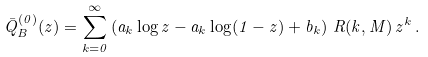Convert formula to latex. <formula><loc_0><loc_0><loc_500><loc_500>\bar { Q } ^ { ( 0 ) } _ { B } ( z ) = \sum ^ { \infty } _ { k = 0 } \left ( a _ { k } \log z - a _ { k } \log ( 1 - z ) + b _ { k } \right ) \, R ( k , M ) \, z ^ { k } \, .</formula> 